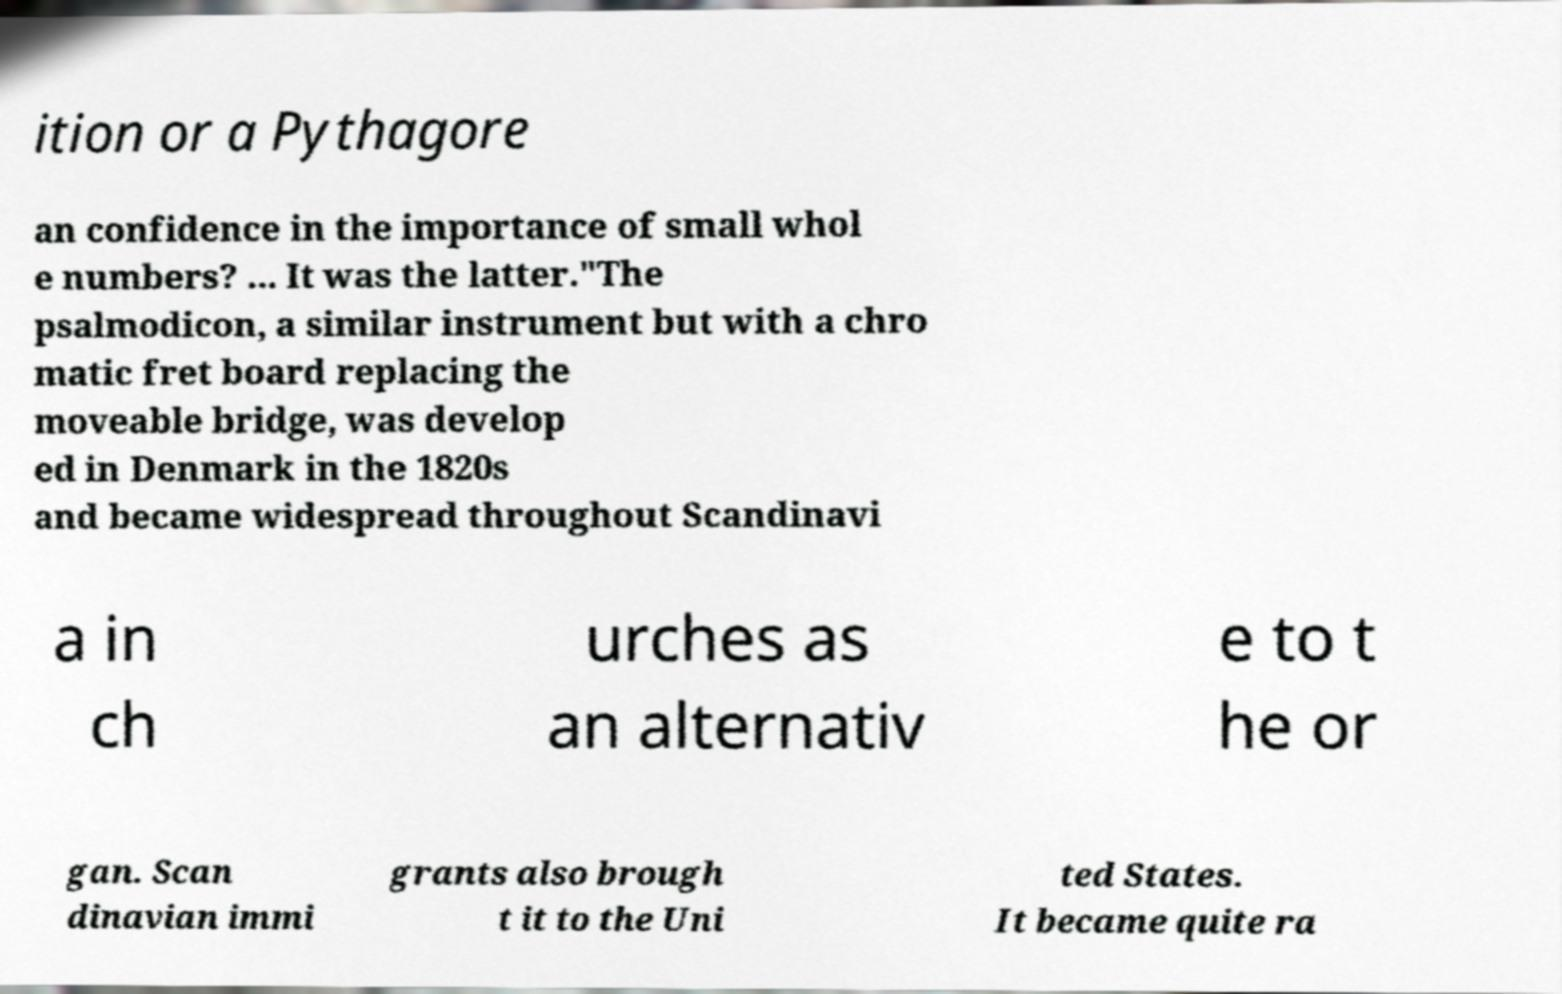Can you accurately transcribe the text from the provided image for me? ition or a Pythagore an confidence in the importance of small whol e numbers? ... It was the latter."The psalmodicon, a similar instrument but with a chro matic fret board replacing the moveable bridge, was develop ed in Denmark in the 1820s and became widespread throughout Scandinavi a in ch urches as an alternativ e to t he or gan. Scan dinavian immi grants also brough t it to the Uni ted States. It became quite ra 